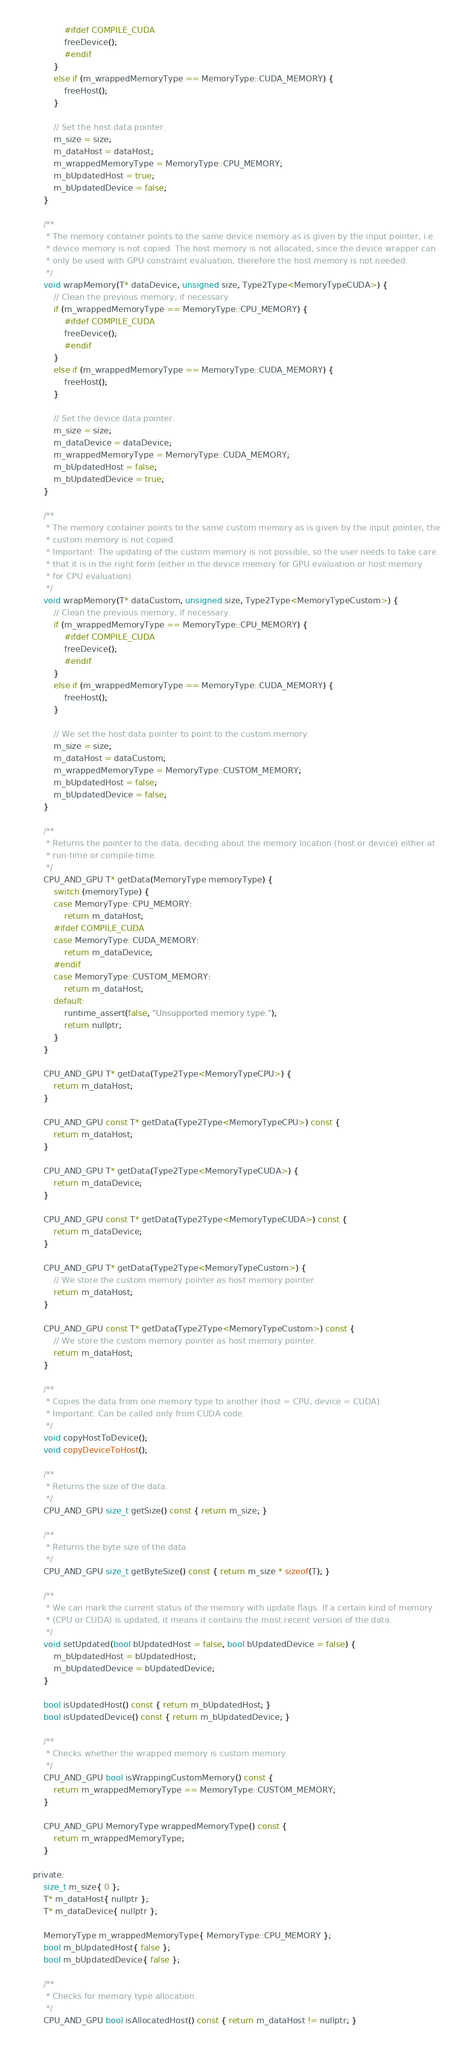<code> <loc_0><loc_0><loc_500><loc_500><_C_>				#ifdef COMPILE_CUDA
				freeDevice();
				#endif
			}
			else if (m_wrappedMemoryType == MemoryType::CUDA_MEMORY) {
				freeHost();
			}

			// Set the host data pointer.
			m_size = size;
			m_dataHost = dataHost;
			m_wrappedMemoryType = MemoryType::CPU_MEMORY;
			m_bUpdatedHost = true;
			m_bUpdatedDevice = false;
		}

		/**
		 * The memory container points to the same device memory as is given by the input pointer, i.e.
		 * device memory is not copied. The host memory is not allocated, since the device wrapper can
		 * only be used with GPU constraint evaluation, therefore the host memory is not needed. 
		 */
		void wrapMemory(T* dataDevice, unsigned size, Type2Type<MemoryTypeCUDA>) {
			// Clean the previous memory, if necessary.
			if (m_wrappedMemoryType == MemoryType::CPU_MEMORY) {
				#ifdef COMPILE_CUDA
				freeDevice();
				#endif
			}
			else if (m_wrappedMemoryType == MemoryType::CUDA_MEMORY) {
				freeHost();
			}

			// Set the device data pointer.
			m_size = size;
			m_dataDevice = dataDevice;
			m_wrappedMemoryType = MemoryType::CUDA_MEMORY;
			m_bUpdatedHost = false;
			m_bUpdatedDevice = true;
		}

		/**
		 * The memory container points to the same custom memory as is given by the input pointer, the
		 * custom memory is not copied.
		 * Important: The updating of the custom memory is not possible, so the user needs to take care
		 * that it is in the right form (either in the device memory for GPU evaluation or host memory
		 * for CPU evaluation).
		 */
		void wrapMemory(T* dataCustom, unsigned size, Type2Type<MemoryTypeCustom>) {
			// Clean the previous memory, if necessary.
			if (m_wrappedMemoryType == MemoryType::CPU_MEMORY) {
				#ifdef COMPILE_CUDA
				freeDevice();
				#endif
			}
			else if (m_wrappedMemoryType == MemoryType::CUDA_MEMORY) {
				freeHost();
			}

			// We set the host data pointer to point to the custom memory.
			m_size = size;
			m_dataHost = dataCustom;
			m_wrappedMemoryType = MemoryType::CUSTOM_MEMORY;
			m_bUpdatedHost = false;
			m_bUpdatedDevice = false;
		}

		/**
		 * Returns the pointer to the data, deciding about the memory location (host or device) either at 
		 * run-time or compile-time.
		 */
		CPU_AND_GPU T* getData(MemoryType memoryType) {
			switch (memoryType) {
			case MemoryType::CPU_MEMORY:
				return m_dataHost;
			#ifdef COMPILE_CUDA
			case MemoryType::CUDA_MEMORY:
				return m_dataDevice;
			#endif
			case MemoryType::CUSTOM_MEMORY:
				return m_dataHost;
			default:
				runtime_assert(false, "Unsupported memory type.");
				return nullptr;
			}
		}

		CPU_AND_GPU T* getData(Type2Type<MemoryTypeCPU>) {
			return m_dataHost;
		}

		CPU_AND_GPU const T* getData(Type2Type<MemoryTypeCPU>) const {
			return m_dataHost;
		}

		CPU_AND_GPU T* getData(Type2Type<MemoryTypeCUDA>) {
			return m_dataDevice;
		}

		CPU_AND_GPU const T* getData(Type2Type<MemoryTypeCUDA>) const {
			return m_dataDevice;
		}

		CPU_AND_GPU T* getData(Type2Type<MemoryTypeCustom>) {
			// We store the custom memory pointer as host memory pointer.
			return m_dataHost; 
		}

		CPU_AND_GPU const T* getData(Type2Type<MemoryTypeCustom>) const {
			// We store the custom memory pointer as host memory pointer.
			return m_dataHost;
		}

		/**
		 * Copies the data from one memory type to another (host = CPU, device = CUDA).
		 * Important: Can be called only from CUDA code.
		 */
		void copyHostToDevice();
		void copyDeviceToHost();

		/**
		 * Returns the size of the data.
		 */
		CPU_AND_GPU size_t getSize() const { return m_size; }

		/**
		 * Returns the byte size of the data.
		 */
		CPU_AND_GPU size_t getByteSize() const { return m_size * sizeof(T); }

		/**
		 * We can mark the current status of the memory with update flags. If a certain kind of memory
		 * (CPU or CUDA) is updated, it means it contains the most recent version of the data.
		 */
		void setUpdated(bool bUpdatedHost = false, bool bUpdatedDevice = false) {
			m_bUpdatedHost = bUpdatedHost;
			m_bUpdatedDevice = bUpdatedDevice;
		}

		bool isUpdatedHost() const { return m_bUpdatedHost; }
		bool isUpdatedDevice() const { return m_bUpdatedDevice; }

		/**
		 * Checks whether the wrapped memory is custom memory.
		 */
		CPU_AND_GPU bool isWrappingCustomMemory() const {
			return m_wrappedMemoryType == MemoryType::CUSTOM_MEMORY;
		}

		CPU_AND_GPU MemoryType wrappedMemoryType() const {
			return m_wrappedMemoryType;
		}

	private:
		size_t m_size{ 0 };
		T* m_dataHost{ nullptr };
		T* m_dataDevice{ nullptr };

		MemoryType m_wrappedMemoryType{ MemoryType::CPU_MEMORY };
		bool m_bUpdatedHost{ false };
		bool m_bUpdatedDevice{ false };

		/**
		 * Checks for memory type allocation.
		 */
		CPU_AND_GPU bool isAllocatedHost() const { return m_dataHost != nullptr; }</code> 